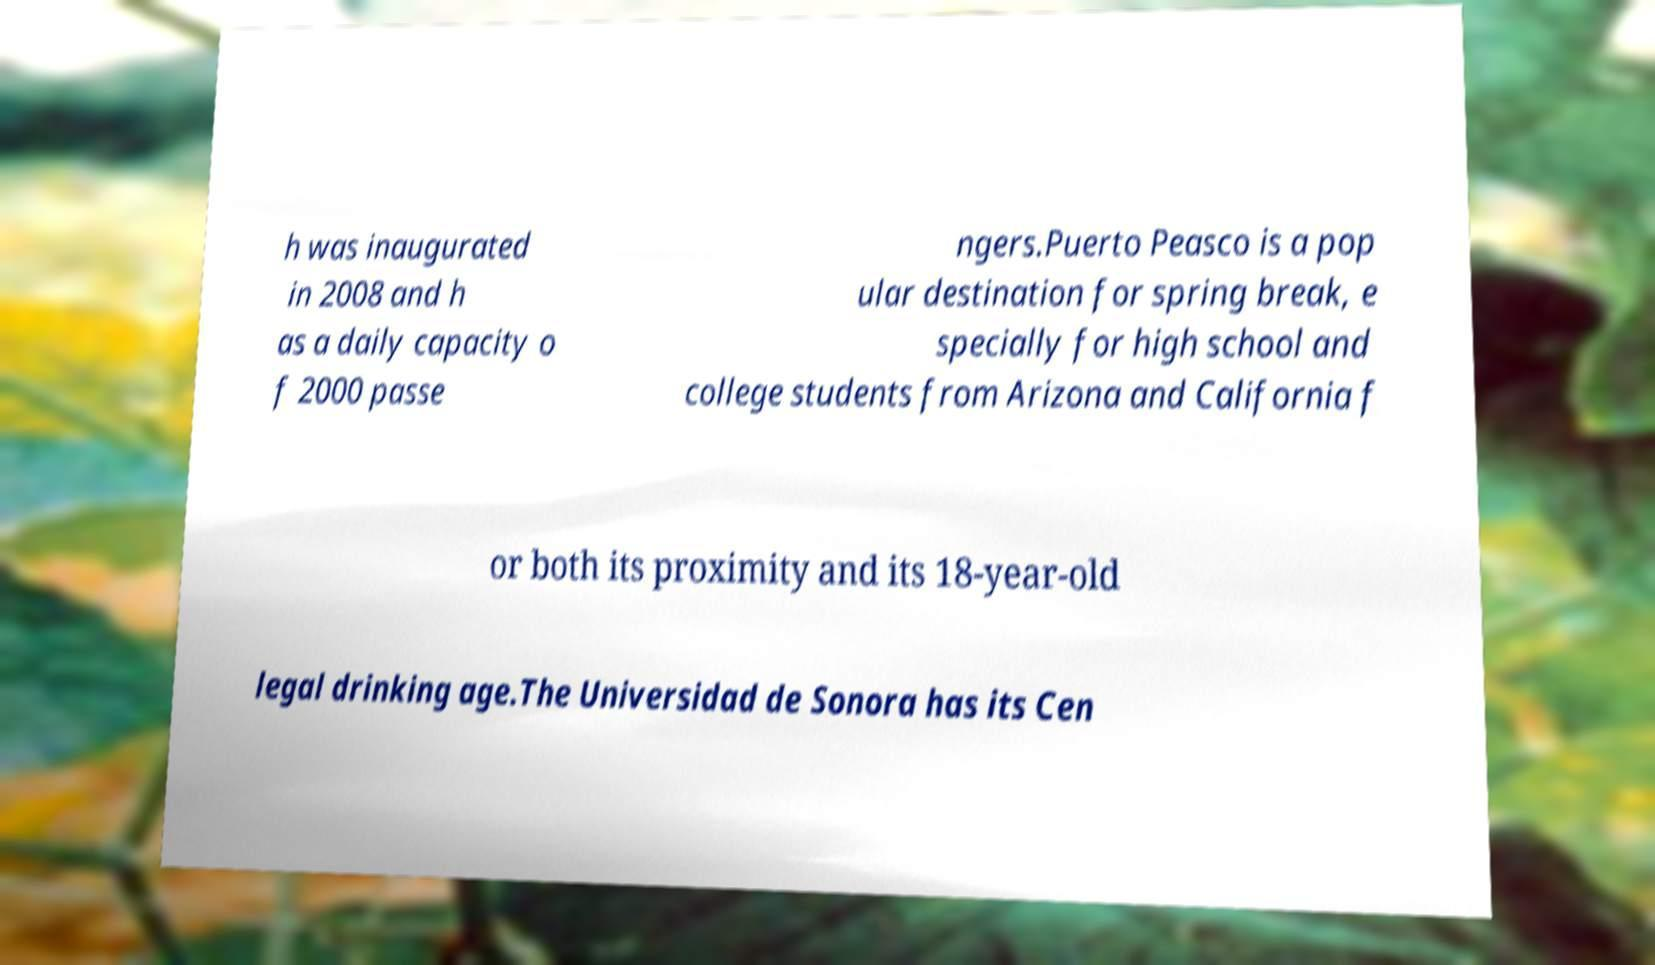Please read and relay the text visible in this image. What does it say? h was inaugurated in 2008 and h as a daily capacity o f 2000 passe ngers.Puerto Peasco is a pop ular destination for spring break, e specially for high school and college students from Arizona and California f or both its proximity and its 18-year-old legal drinking age.The Universidad de Sonora has its Cen 